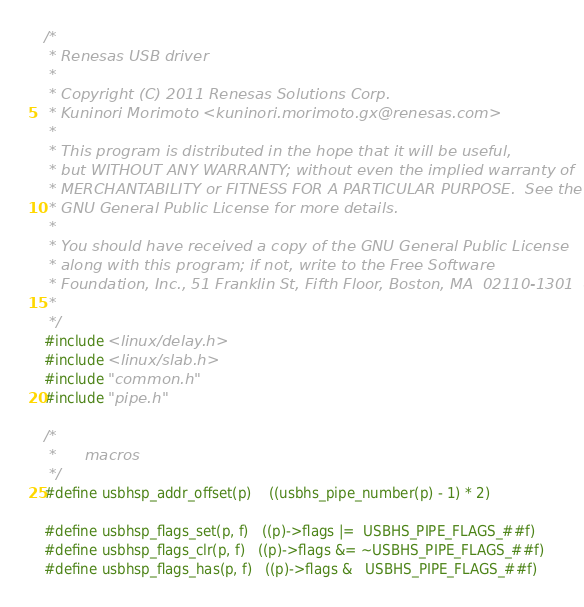<code> <loc_0><loc_0><loc_500><loc_500><_C_>/*
 * Renesas USB driver
 *
 * Copyright (C) 2011 Renesas Solutions Corp.
 * Kuninori Morimoto <kuninori.morimoto.gx@renesas.com>
 *
 * This program is distributed in the hope that it will be useful,
 * but WITHOUT ANY WARRANTY; without even the implied warranty of
 * MERCHANTABILITY or FITNESS FOR A PARTICULAR PURPOSE.  See the
 * GNU General Public License for more details.
 *
 * You should have received a copy of the GNU General Public License
 * along with this program; if not, write to the Free Software
 * Foundation, Inc., 51 Franklin St, Fifth Floor, Boston, MA  02110-1301  USA
 *
 */
#include <linux/delay.h>
#include <linux/slab.h>
#include "common.h"
#include "pipe.h"

/*
 *		macros
 */
#define usbhsp_addr_offset(p)	((usbhs_pipe_number(p) - 1) * 2)

#define usbhsp_flags_set(p, f)	((p)->flags |=  USBHS_PIPE_FLAGS_##f)
#define usbhsp_flags_clr(p, f)	((p)->flags &= ~USBHS_PIPE_FLAGS_##f)
#define usbhsp_flags_has(p, f)	((p)->flags &   USBHS_PIPE_FLAGS_##f)</code> 